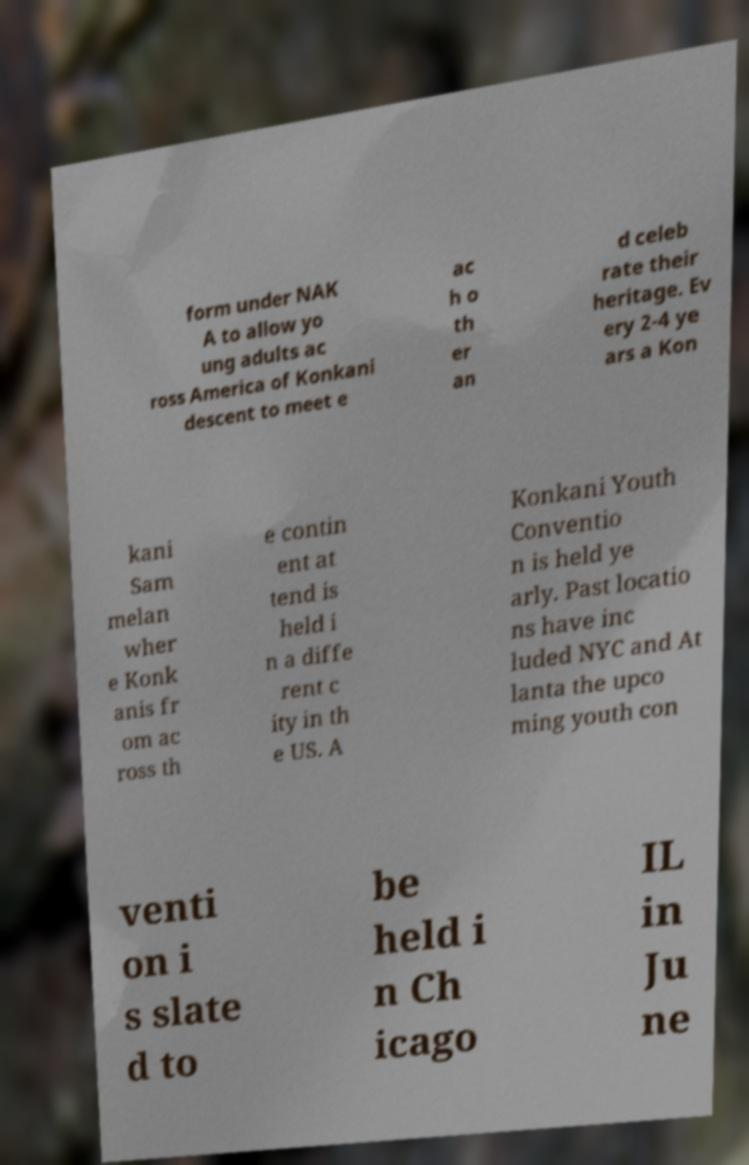I need the written content from this picture converted into text. Can you do that? form under NAK A to allow yo ung adults ac ross America of Konkani descent to meet e ac h o th er an d celeb rate their heritage. Ev ery 2-4 ye ars a Kon kani Sam melan wher e Konk anis fr om ac ross th e contin ent at tend is held i n a diffe rent c ity in th e US. A Konkani Youth Conventio n is held ye arly. Past locatio ns have inc luded NYC and At lanta the upco ming youth con venti on i s slate d to be held i n Ch icago IL in Ju ne 